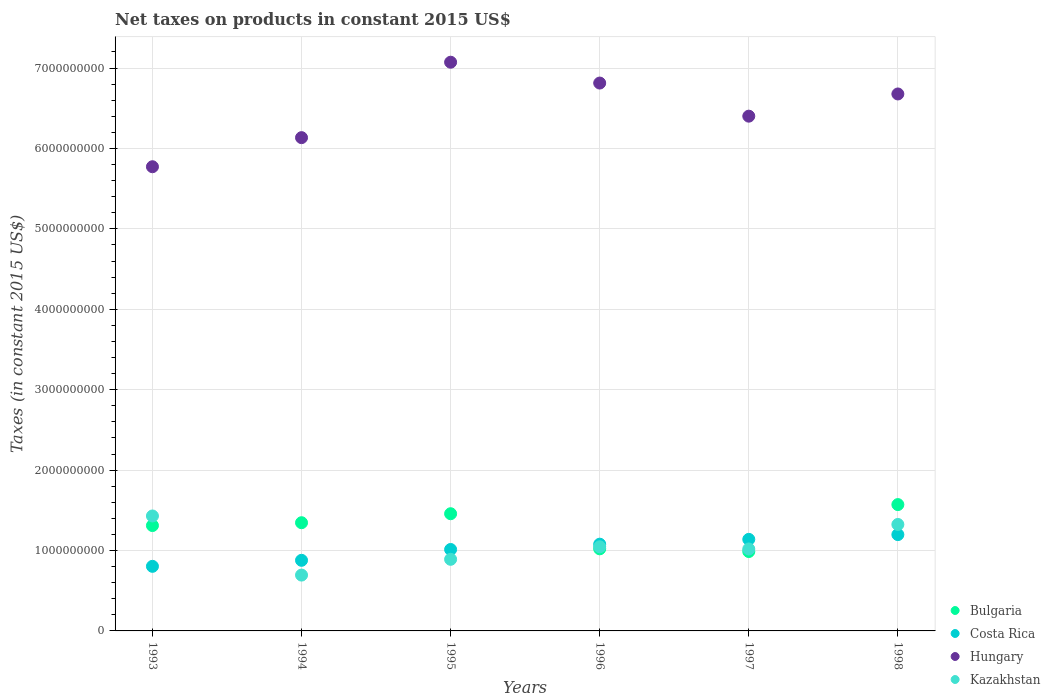How many different coloured dotlines are there?
Keep it short and to the point. 4. What is the net taxes on products in Bulgaria in 1998?
Your answer should be very brief. 1.57e+09. Across all years, what is the maximum net taxes on products in Bulgaria?
Offer a very short reply. 1.57e+09. Across all years, what is the minimum net taxes on products in Kazakhstan?
Your answer should be compact. 6.94e+08. In which year was the net taxes on products in Bulgaria minimum?
Your response must be concise. 1997. What is the total net taxes on products in Kazakhstan in the graph?
Ensure brevity in your answer.  6.40e+09. What is the difference between the net taxes on products in Bulgaria in 1993 and that in 1994?
Give a very brief answer. -3.53e+07. What is the difference between the net taxes on products in Hungary in 1993 and the net taxes on products in Costa Rica in 1996?
Provide a succinct answer. 4.69e+09. What is the average net taxes on products in Costa Rica per year?
Offer a terse response. 1.02e+09. In the year 1993, what is the difference between the net taxes on products in Bulgaria and net taxes on products in Costa Rica?
Offer a very short reply. 5.07e+08. In how many years, is the net taxes on products in Bulgaria greater than 6400000000 US$?
Provide a succinct answer. 0. What is the ratio of the net taxes on products in Kazakhstan in 1994 to that in 1997?
Provide a succinct answer. 0.68. Is the net taxes on products in Hungary in 1993 less than that in 1995?
Make the answer very short. Yes. Is the difference between the net taxes on products in Bulgaria in 1995 and 1998 greater than the difference between the net taxes on products in Costa Rica in 1995 and 1998?
Offer a very short reply. Yes. What is the difference between the highest and the second highest net taxes on products in Bulgaria?
Give a very brief answer. 1.14e+08. What is the difference between the highest and the lowest net taxes on products in Bulgaria?
Your answer should be very brief. 5.84e+08. In how many years, is the net taxes on products in Bulgaria greater than the average net taxes on products in Bulgaria taken over all years?
Provide a succinct answer. 4. Is it the case that in every year, the sum of the net taxes on products in Hungary and net taxes on products in Costa Rica  is greater than the net taxes on products in Bulgaria?
Provide a succinct answer. Yes. Does the net taxes on products in Costa Rica monotonically increase over the years?
Keep it short and to the point. Yes. Is the net taxes on products in Hungary strictly greater than the net taxes on products in Costa Rica over the years?
Your answer should be compact. Yes. How many dotlines are there?
Offer a very short reply. 4. Are the values on the major ticks of Y-axis written in scientific E-notation?
Your response must be concise. No. Does the graph contain any zero values?
Offer a very short reply. No. Does the graph contain grids?
Offer a very short reply. Yes. Where does the legend appear in the graph?
Give a very brief answer. Bottom right. How are the legend labels stacked?
Ensure brevity in your answer.  Vertical. What is the title of the graph?
Make the answer very short. Net taxes on products in constant 2015 US$. Does "Liechtenstein" appear as one of the legend labels in the graph?
Offer a terse response. No. What is the label or title of the Y-axis?
Make the answer very short. Taxes (in constant 2015 US$). What is the Taxes (in constant 2015 US$) in Bulgaria in 1993?
Give a very brief answer. 1.31e+09. What is the Taxes (in constant 2015 US$) in Costa Rica in 1993?
Provide a short and direct response. 8.03e+08. What is the Taxes (in constant 2015 US$) of Hungary in 1993?
Offer a terse response. 5.77e+09. What is the Taxes (in constant 2015 US$) of Kazakhstan in 1993?
Ensure brevity in your answer.  1.43e+09. What is the Taxes (in constant 2015 US$) in Bulgaria in 1994?
Keep it short and to the point. 1.35e+09. What is the Taxes (in constant 2015 US$) of Costa Rica in 1994?
Offer a terse response. 8.78e+08. What is the Taxes (in constant 2015 US$) of Hungary in 1994?
Provide a succinct answer. 6.13e+09. What is the Taxes (in constant 2015 US$) in Kazakhstan in 1994?
Your answer should be compact. 6.94e+08. What is the Taxes (in constant 2015 US$) of Bulgaria in 1995?
Provide a short and direct response. 1.46e+09. What is the Taxes (in constant 2015 US$) of Costa Rica in 1995?
Offer a terse response. 1.01e+09. What is the Taxes (in constant 2015 US$) in Hungary in 1995?
Make the answer very short. 7.07e+09. What is the Taxes (in constant 2015 US$) in Kazakhstan in 1995?
Provide a short and direct response. 8.91e+08. What is the Taxes (in constant 2015 US$) of Bulgaria in 1996?
Your answer should be compact. 1.02e+09. What is the Taxes (in constant 2015 US$) of Costa Rica in 1996?
Give a very brief answer. 1.08e+09. What is the Taxes (in constant 2015 US$) in Hungary in 1996?
Your answer should be very brief. 6.81e+09. What is the Taxes (in constant 2015 US$) in Kazakhstan in 1996?
Your response must be concise. 1.05e+09. What is the Taxes (in constant 2015 US$) of Bulgaria in 1997?
Give a very brief answer. 9.87e+08. What is the Taxes (in constant 2015 US$) in Costa Rica in 1997?
Your answer should be very brief. 1.14e+09. What is the Taxes (in constant 2015 US$) in Hungary in 1997?
Your answer should be very brief. 6.40e+09. What is the Taxes (in constant 2015 US$) in Kazakhstan in 1997?
Make the answer very short. 1.02e+09. What is the Taxes (in constant 2015 US$) of Bulgaria in 1998?
Offer a very short reply. 1.57e+09. What is the Taxes (in constant 2015 US$) of Costa Rica in 1998?
Your response must be concise. 1.20e+09. What is the Taxes (in constant 2015 US$) of Hungary in 1998?
Make the answer very short. 6.68e+09. What is the Taxes (in constant 2015 US$) of Kazakhstan in 1998?
Ensure brevity in your answer.  1.32e+09. Across all years, what is the maximum Taxes (in constant 2015 US$) of Bulgaria?
Ensure brevity in your answer.  1.57e+09. Across all years, what is the maximum Taxes (in constant 2015 US$) of Costa Rica?
Give a very brief answer. 1.20e+09. Across all years, what is the maximum Taxes (in constant 2015 US$) of Hungary?
Provide a succinct answer. 7.07e+09. Across all years, what is the maximum Taxes (in constant 2015 US$) in Kazakhstan?
Your response must be concise. 1.43e+09. Across all years, what is the minimum Taxes (in constant 2015 US$) in Bulgaria?
Your response must be concise. 9.87e+08. Across all years, what is the minimum Taxes (in constant 2015 US$) in Costa Rica?
Provide a short and direct response. 8.03e+08. Across all years, what is the minimum Taxes (in constant 2015 US$) in Hungary?
Offer a terse response. 5.77e+09. Across all years, what is the minimum Taxes (in constant 2015 US$) in Kazakhstan?
Provide a short and direct response. 6.94e+08. What is the total Taxes (in constant 2015 US$) of Bulgaria in the graph?
Ensure brevity in your answer.  7.69e+09. What is the total Taxes (in constant 2015 US$) in Costa Rica in the graph?
Provide a short and direct response. 6.11e+09. What is the total Taxes (in constant 2015 US$) of Hungary in the graph?
Give a very brief answer. 3.89e+1. What is the total Taxes (in constant 2015 US$) of Kazakhstan in the graph?
Provide a succinct answer. 6.40e+09. What is the difference between the Taxes (in constant 2015 US$) of Bulgaria in 1993 and that in 1994?
Your response must be concise. -3.53e+07. What is the difference between the Taxes (in constant 2015 US$) in Costa Rica in 1993 and that in 1994?
Offer a very short reply. -7.48e+07. What is the difference between the Taxes (in constant 2015 US$) of Hungary in 1993 and that in 1994?
Keep it short and to the point. -3.62e+08. What is the difference between the Taxes (in constant 2015 US$) of Kazakhstan in 1993 and that in 1994?
Provide a short and direct response. 7.35e+08. What is the difference between the Taxes (in constant 2015 US$) of Bulgaria in 1993 and that in 1995?
Provide a succinct answer. -1.47e+08. What is the difference between the Taxes (in constant 2015 US$) in Costa Rica in 1993 and that in 1995?
Provide a short and direct response. -2.10e+08. What is the difference between the Taxes (in constant 2015 US$) of Hungary in 1993 and that in 1995?
Your response must be concise. -1.30e+09. What is the difference between the Taxes (in constant 2015 US$) of Kazakhstan in 1993 and that in 1995?
Ensure brevity in your answer.  5.39e+08. What is the difference between the Taxes (in constant 2015 US$) of Bulgaria in 1993 and that in 1996?
Your response must be concise. 2.89e+08. What is the difference between the Taxes (in constant 2015 US$) in Costa Rica in 1993 and that in 1996?
Make the answer very short. -2.75e+08. What is the difference between the Taxes (in constant 2015 US$) of Hungary in 1993 and that in 1996?
Offer a terse response. -1.04e+09. What is the difference between the Taxes (in constant 2015 US$) of Kazakhstan in 1993 and that in 1996?
Ensure brevity in your answer.  3.83e+08. What is the difference between the Taxes (in constant 2015 US$) in Bulgaria in 1993 and that in 1997?
Keep it short and to the point. 3.23e+08. What is the difference between the Taxes (in constant 2015 US$) in Costa Rica in 1993 and that in 1997?
Offer a very short reply. -3.35e+08. What is the difference between the Taxes (in constant 2015 US$) in Hungary in 1993 and that in 1997?
Provide a short and direct response. -6.29e+08. What is the difference between the Taxes (in constant 2015 US$) of Kazakhstan in 1993 and that in 1997?
Provide a succinct answer. 4.10e+08. What is the difference between the Taxes (in constant 2015 US$) of Bulgaria in 1993 and that in 1998?
Give a very brief answer. -2.61e+08. What is the difference between the Taxes (in constant 2015 US$) of Costa Rica in 1993 and that in 1998?
Your response must be concise. -3.95e+08. What is the difference between the Taxes (in constant 2015 US$) of Hungary in 1993 and that in 1998?
Provide a succinct answer. -9.05e+08. What is the difference between the Taxes (in constant 2015 US$) in Kazakhstan in 1993 and that in 1998?
Provide a succinct answer. 1.06e+08. What is the difference between the Taxes (in constant 2015 US$) in Bulgaria in 1994 and that in 1995?
Give a very brief answer. -1.12e+08. What is the difference between the Taxes (in constant 2015 US$) in Costa Rica in 1994 and that in 1995?
Your answer should be compact. -1.35e+08. What is the difference between the Taxes (in constant 2015 US$) of Hungary in 1994 and that in 1995?
Offer a very short reply. -9.38e+08. What is the difference between the Taxes (in constant 2015 US$) of Kazakhstan in 1994 and that in 1995?
Your response must be concise. -1.96e+08. What is the difference between the Taxes (in constant 2015 US$) in Bulgaria in 1994 and that in 1996?
Ensure brevity in your answer.  3.25e+08. What is the difference between the Taxes (in constant 2015 US$) in Costa Rica in 1994 and that in 1996?
Your answer should be compact. -2.01e+08. What is the difference between the Taxes (in constant 2015 US$) in Hungary in 1994 and that in 1996?
Keep it short and to the point. -6.79e+08. What is the difference between the Taxes (in constant 2015 US$) in Kazakhstan in 1994 and that in 1996?
Offer a very short reply. -3.52e+08. What is the difference between the Taxes (in constant 2015 US$) in Bulgaria in 1994 and that in 1997?
Provide a succinct answer. 3.59e+08. What is the difference between the Taxes (in constant 2015 US$) of Costa Rica in 1994 and that in 1997?
Give a very brief answer. -2.61e+08. What is the difference between the Taxes (in constant 2015 US$) of Hungary in 1994 and that in 1997?
Provide a succinct answer. -2.67e+08. What is the difference between the Taxes (in constant 2015 US$) of Kazakhstan in 1994 and that in 1997?
Your answer should be very brief. -3.25e+08. What is the difference between the Taxes (in constant 2015 US$) of Bulgaria in 1994 and that in 1998?
Offer a terse response. -2.25e+08. What is the difference between the Taxes (in constant 2015 US$) in Costa Rica in 1994 and that in 1998?
Your answer should be very brief. -3.20e+08. What is the difference between the Taxes (in constant 2015 US$) of Hungary in 1994 and that in 1998?
Your answer should be compact. -5.43e+08. What is the difference between the Taxes (in constant 2015 US$) of Kazakhstan in 1994 and that in 1998?
Provide a short and direct response. -6.30e+08. What is the difference between the Taxes (in constant 2015 US$) of Bulgaria in 1995 and that in 1996?
Give a very brief answer. 4.36e+08. What is the difference between the Taxes (in constant 2015 US$) of Costa Rica in 1995 and that in 1996?
Keep it short and to the point. -6.58e+07. What is the difference between the Taxes (in constant 2015 US$) in Hungary in 1995 and that in 1996?
Your response must be concise. 2.59e+08. What is the difference between the Taxes (in constant 2015 US$) of Kazakhstan in 1995 and that in 1996?
Your response must be concise. -1.56e+08. What is the difference between the Taxes (in constant 2015 US$) in Bulgaria in 1995 and that in 1997?
Give a very brief answer. 4.70e+08. What is the difference between the Taxes (in constant 2015 US$) in Costa Rica in 1995 and that in 1997?
Keep it short and to the point. -1.26e+08. What is the difference between the Taxes (in constant 2015 US$) in Hungary in 1995 and that in 1997?
Offer a terse response. 6.71e+08. What is the difference between the Taxes (in constant 2015 US$) in Kazakhstan in 1995 and that in 1997?
Offer a very short reply. -1.29e+08. What is the difference between the Taxes (in constant 2015 US$) of Bulgaria in 1995 and that in 1998?
Your answer should be very brief. -1.14e+08. What is the difference between the Taxes (in constant 2015 US$) of Costa Rica in 1995 and that in 1998?
Keep it short and to the point. -1.85e+08. What is the difference between the Taxes (in constant 2015 US$) in Hungary in 1995 and that in 1998?
Offer a terse response. 3.95e+08. What is the difference between the Taxes (in constant 2015 US$) of Kazakhstan in 1995 and that in 1998?
Your answer should be very brief. -4.33e+08. What is the difference between the Taxes (in constant 2015 US$) in Bulgaria in 1996 and that in 1997?
Make the answer very short. 3.38e+07. What is the difference between the Taxes (in constant 2015 US$) of Costa Rica in 1996 and that in 1997?
Make the answer very short. -6.00e+07. What is the difference between the Taxes (in constant 2015 US$) in Hungary in 1996 and that in 1997?
Offer a terse response. 4.12e+08. What is the difference between the Taxes (in constant 2015 US$) of Kazakhstan in 1996 and that in 1997?
Give a very brief answer. 2.69e+07. What is the difference between the Taxes (in constant 2015 US$) of Bulgaria in 1996 and that in 1998?
Provide a succinct answer. -5.50e+08. What is the difference between the Taxes (in constant 2015 US$) in Costa Rica in 1996 and that in 1998?
Offer a terse response. -1.19e+08. What is the difference between the Taxes (in constant 2015 US$) of Hungary in 1996 and that in 1998?
Make the answer very short. 1.36e+08. What is the difference between the Taxes (in constant 2015 US$) of Kazakhstan in 1996 and that in 1998?
Offer a terse response. -2.78e+08. What is the difference between the Taxes (in constant 2015 US$) of Bulgaria in 1997 and that in 1998?
Your response must be concise. -5.84e+08. What is the difference between the Taxes (in constant 2015 US$) of Costa Rica in 1997 and that in 1998?
Offer a terse response. -5.92e+07. What is the difference between the Taxes (in constant 2015 US$) of Hungary in 1997 and that in 1998?
Offer a terse response. -2.76e+08. What is the difference between the Taxes (in constant 2015 US$) in Kazakhstan in 1997 and that in 1998?
Your answer should be very brief. -3.05e+08. What is the difference between the Taxes (in constant 2015 US$) in Bulgaria in 1993 and the Taxes (in constant 2015 US$) in Costa Rica in 1994?
Give a very brief answer. 4.32e+08. What is the difference between the Taxes (in constant 2015 US$) in Bulgaria in 1993 and the Taxes (in constant 2015 US$) in Hungary in 1994?
Offer a terse response. -4.82e+09. What is the difference between the Taxes (in constant 2015 US$) in Bulgaria in 1993 and the Taxes (in constant 2015 US$) in Kazakhstan in 1994?
Your answer should be very brief. 6.16e+08. What is the difference between the Taxes (in constant 2015 US$) in Costa Rica in 1993 and the Taxes (in constant 2015 US$) in Hungary in 1994?
Give a very brief answer. -5.33e+09. What is the difference between the Taxes (in constant 2015 US$) in Costa Rica in 1993 and the Taxes (in constant 2015 US$) in Kazakhstan in 1994?
Give a very brief answer. 1.09e+08. What is the difference between the Taxes (in constant 2015 US$) of Hungary in 1993 and the Taxes (in constant 2015 US$) of Kazakhstan in 1994?
Offer a very short reply. 5.08e+09. What is the difference between the Taxes (in constant 2015 US$) in Bulgaria in 1993 and the Taxes (in constant 2015 US$) in Costa Rica in 1995?
Your response must be concise. 2.98e+08. What is the difference between the Taxes (in constant 2015 US$) in Bulgaria in 1993 and the Taxes (in constant 2015 US$) in Hungary in 1995?
Offer a terse response. -5.76e+09. What is the difference between the Taxes (in constant 2015 US$) of Bulgaria in 1993 and the Taxes (in constant 2015 US$) of Kazakhstan in 1995?
Make the answer very short. 4.20e+08. What is the difference between the Taxes (in constant 2015 US$) of Costa Rica in 1993 and the Taxes (in constant 2015 US$) of Hungary in 1995?
Your answer should be very brief. -6.27e+09. What is the difference between the Taxes (in constant 2015 US$) of Costa Rica in 1993 and the Taxes (in constant 2015 US$) of Kazakhstan in 1995?
Offer a very short reply. -8.73e+07. What is the difference between the Taxes (in constant 2015 US$) in Hungary in 1993 and the Taxes (in constant 2015 US$) in Kazakhstan in 1995?
Provide a short and direct response. 4.88e+09. What is the difference between the Taxes (in constant 2015 US$) in Bulgaria in 1993 and the Taxes (in constant 2015 US$) in Costa Rica in 1996?
Provide a short and direct response. 2.32e+08. What is the difference between the Taxes (in constant 2015 US$) in Bulgaria in 1993 and the Taxes (in constant 2015 US$) in Hungary in 1996?
Offer a terse response. -5.50e+09. What is the difference between the Taxes (in constant 2015 US$) in Bulgaria in 1993 and the Taxes (in constant 2015 US$) in Kazakhstan in 1996?
Provide a short and direct response. 2.64e+08. What is the difference between the Taxes (in constant 2015 US$) in Costa Rica in 1993 and the Taxes (in constant 2015 US$) in Hungary in 1996?
Provide a succinct answer. -6.01e+09. What is the difference between the Taxes (in constant 2015 US$) of Costa Rica in 1993 and the Taxes (in constant 2015 US$) of Kazakhstan in 1996?
Offer a terse response. -2.43e+08. What is the difference between the Taxes (in constant 2015 US$) in Hungary in 1993 and the Taxes (in constant 2015 US$) in Kazakhstan in 1996?
Your answer should be compact. 4.73e+09. What is the difference between the Taxes (in constant 2015 US$) of Bulgaria in 1993 and the Taxes (in constant 2015 US$) of Costa Rica in 1997?
Provide a succinct answer. 1.72e+08. What is the difference between the Taxes (in constant 2015 US$) of Bulgaria in 1993 and the Taxes (in constant 2015 US$) of Hungary in 1997?
Provide a succinct answer. -5.09e+09. What is the difference between the Taxes (in constant 2015 US$) in Bulgaria in 1993 and the Taxes (in constant 2015 US$) in Kazakhstan in 1997?
Your response must be concise. 2.91e+08. What is the difference between the Taxes (in constant 2015 US$) of Costa Rica in 1993 and the Taxes (in constant 2015 US$) of Hungary in 1997?
Provide a succinct answer. -5.60e+09. What is the difference between the Taxes (in constant 2015 US$) in Costa Rica in 1993 and the Taxes (in constant 2015 US$) in Kazakhstan in 1997?
Keep it short and to the point. -2.16e+08. What is the difference between the Taxes (in constant 2015 US$) of Hungary in 1993 and the Taxes (in constant 2015 US$) of Kazakhstan in 1997?
Ensure brevity in your answer.  4.75e+09. What is the difference between the Taxes (in constant 2015 US$) in Bulgaria in 1993 and the Taxes (in constant 2015 US$) in Costa Rica in 1998?
Your answer should be compact. 1.13e+08. What is the difference between the Taxes (in constant 2015 US$) in Bulgaria in 1993 and the Taxes (in constant 2015 US$) in Hungary in 1998?
Ensure brevity in your answer.  -5.37e+09. What is the difference between the Taxes (in constant 2015 US$) in Bulgaria in 1993 and the Taxes (in constant 2015 US$) in Kazakhstan in 1998?
Keep it short and to the point. -1.35e+07. What is the difference between the Taxes (in constant 2015 US$) of Costa Rica in 1993 and the Taxes (in constant 2015 US$) of Hungary in 1998?
Your answer should be compact. -5.87e+09. What is the difference between the Taxes (in constant 2015 US$) in Costa Rica in 1993 and the Taxes (in constant 2015 US$) in Kazakhstan in 1998?
Ensure brevity in your answer.  -5.21e+08. What is the difference between the Taxes (in constant 2015 US$) of Hungary in 1993 and the Taxes (in constant 2015 US$) of Kazakhstan in 1998?
Your response must be concise. 4.45e+09. What is the difference between the Taxes (in constant 2015 US$) in Bulgaria in 1994 and the Taxes (in constant 2015 US$) in Costa Rica in 1995?
Provide a succinct answer. 3.33e+08. What is the difference between the Taxes (in constant 2015 US$) of Bulgaria in 1994 and the Taxes (in constant 2015 US$) of Hungary in 1995?
Give a very brief answer. -5.73e+09. What is the difference between the Taxes (in constant 2015 US$) of Bulgaria in 1994 and the Taxes (in constant 2015 US$) of Kazakhstan in 1995?
Give a very brief answer. 4.55e+08. What is the difference between the Taxes (in constant 2015 US$) of Costa Rica in 1994 and the Taxes (in constant 2015 US$) of Hungary in 1995?
Provide a short and direct response. -6.19e+09. What is the difference between the Taxes (in constant 2015 US$) of Costa Rica in 1994 and the Taxes (in constant 2015 US$) of Kazakhstan in 1995?
Keep it short and to the point. -1.25e+07. What is the difference between the Taxes (in constant 2015 US$) of Hungary in 1994 and the Taxes (in constant 2015 US$) of Kazakhstan in 1995?
Your answer should be very brief. 5.24e+09. What is the difference between the Taxes (in constant 2015 US$) in Bulgaria in 1994 and the Taxes (in constant 2015 US$) in Costa Rica in 1996?
Give a very brief answer. 2.67e+08. What is the difference between the Taxes (in constant 2015 US$) of Bulgaria in 1994 and the Taxes (in constant 2015 US$) of Hungary in 1996?
Make the answer very short. -5.47e+09. What is the difference between the Taxes (in constant 2015 US$) of Bulgaria in 1994 and the Taxes (in constant 2015 US$) of Kazakhstan in 1996?
Make the answer very short. 3.00e+08. What is the difference between the Taxes (in constant 2015 US$) of Costa Rica in 1994 and the Taxes (in constant 2015 US$) of Hungary in 1996?
Offer a terse response. -5.94e+09. What is the difference between the Taxes (in constant 2015 US$) in Costa Rica in 1994 and the Taxes (in constant 2015 US$) in Kazakhstan in 1996?
Your answer should be very brief. -1.68e+08. What is the difference between the Taxes (in constant 2015 US$) in Hungary in 1994 and the Taxes (in constant 2015 US$) in Kazakhstan in 1996?
Your response must be concise. 5.09e+09. What is the difference between the Taxes (in constant 2015 US$) of Bulgaria in 1994 and the Taxes (in constant 2015 US$) of Costa Rica in 1997?
Your answer should be very brief. 2.07e+08. What is the difference between the Taxes (in constant 2015 US$) in Bulgaria in 1994 and the Taxes (in constant 2015 US$) in Hungary in 1997?
Ensure brevity in your answer.  -5.06e+09. What is the difference between the Taxes (in constant 2015 US$) in Bulgaria in 1994 and the Taxes (in constant 2015 US$) in Kazakhstan in 1997?
Provide a succinct answer. 3.27e+08. What is the difference between the Taxes (in constant 2015 US$) in Costa Rica in 1994 and the Taxes (in constant 2015 US$) in Hungary in 1997?
Keep it short and to the point. -5.52e+09. What is the difference between the Taxes (in constant 2015 US$) of Costa Rica in 1994 and the Taxes (in constant 2015 US$) of Kazakhstan in 1997?
Your answer should be compact. -1.41e+08. What is the difference between the Taxes (in constant 2015 US$) in Hungary in 1994 and the Taxes (in constant 2015 US$) in Kazakhstan in 1997?
Your answer should be very brief. 5.12e+09. What is the difference between the Taxes (in constant 2015 US$) in Bulgaria in 1994 and the Taxes (in constant 2015 US$) in Costa Rica in 1998?
Ensure brevity in your answer.  1.48e+08. What is the difference between the Taxes (in constant 2015 US$) of Bulgaria in 1994 and the Taxes (in constant 2015 US$) of Hungary in 1998?
Make the answer very short. -5.33e+09. What is the difference between the Taxes (in constant 2015 US$) in Bulgaria in 1994 and the Taxes (in constant 2015 US$) in Kazakhstan in 1998?
Keep it short and to the point. 2.17e+07. What is the difference between the Taxes (in constant 2015 US$) in Costa Rica in 1994 and the Taxes (in constant 2015 US$) in Hungary in 1998?
Your answer should be compact. -5.80e+09. What is the difference between the Taxes (in constant 2015 US$) in Costa Rica in 1994 and the Taxes (in constant 2015 US$) in Kazakhstan in 1998?
Offer a very short reply. -4.46e+08. What is the difference between the Taxes (in constant 2015 US$) of Hungary in 1994 and the Taxes (in constant 2015 US$) of Kazakhstan in 1998?
Your answer should be compact. 4.81e+09. What is the difference between the Taxes (in constant 2015 US$) in Bulgaria in 1995 and the Taxes (in constant 2015 US$) in Costa Rica in 1996?
Keep it short and to the point. 3.79e+08. What is the difference between the Taxes (in constant 2015 US$) in Bulgaria in 1995 and the Taxes (in constant 2015 US$) in Hungary in 1996?
Provide a succinct answer. -5.36e+09. What is the difference between the Taxes (in constant 2015 US$) in Bulgaria in 1995 and the Taxes (in constant 2015 US$) in Kazakhstan in 1996?
Offer a very short reply. 4.11e+08. What is the difference between the Taxes (in constant 2015 US$) in Costa Rica in 1995 and the Taxes (in constant 2015 US$) in Hungary in 1996?
Provide a succinct answer. -5.80e+09. What is the difference between the Taxes (in constant 2015 US$) in Costa Rica in 1995 and the Taxes (in constant 2015 US$) in Kazakhstan in 1996?
Offer a terse response. -3.33e+07. What is the difference between the Taxes (in constant 2015 US$) in Hungary in 1995 and the Taxes (in constant 2015 US$) in Kazakhstan in 1996?
Give a very brief answer. 6.03e+09. What is the difference between the Taxes (in constant 2015 US$) of Bulgaria in 1995 and the Taxes (in constant 2015 US$) of Costa Rica in 1997?
Make the answer very short. 3.19e+08. What is the difference between the Taxes (in constant 2015 US$) of Bulgaria in 1995 and the Taxes (in constant 2015 US$) of Hungary in 1997?
Offer a terse response. -4.94e+09. What is the difference between the Taxes (in constant 2015 US$) of Bulgaria in 1995 and the Taxes (in constant 2015 US$) of Kazakhstan in 1997?
Your response must be concise. 4.38e+08. What is the difference between the Taxes (in constant 2015 US$) in Costa Rica in 1995 and the Taxes (in constant 2015 US$) in Hungary in 1997?
Make the answer very short. -5.39e+09. What is the difference between the Taxes (in constant 2015 US$) of Costa Rica in 1995 and the Taxes (in constant 2015 US$) of Kazakhstan in 1997?
Give a very brief answer. -6.32e+06. What is the difference between the Taxes (in constant 2015 US$) of Hungary in 1995 and the Taxes (in constant 2015 US$) of Kazakhstan in 1997?
Make the answer very short. 6.05e+09. What is the difference between the Taxes (in constant 2015 US$) in Bulgaria in 1995 and the Taxes (in constant 2015 US$) in Costa Rica in 1998?
Provide a succinct answer. 2.60e+08. What is the difference between the Taxes (in constant 2015 US$) of Bulgaria in 1995 and the Taxes (in constant 2015 US$) of Hungary in 1998?
Provide a succinct answer. -5.22e+09. What is the difference between the Taxes (in constant 2015 US$) of Bulgaria in 1995 and the Taxes (in constant 2015 US$) of Kazakhstan in 1998?
Offer a terse response. 1.34e+08. What is the difference between the Taxes (in constant 2015 US$) of Costa Rica in 1995 and the Taxes (in constant 2015 US$) of Hungary in 1998?
Keep it short and to the point. -5.67e+09. What is the difference between the Taxes (in constant 2015 US$) of Costa Rica in 1995 and the Taxes (in constant 2015 US$) of Kazakhstan in 1998?
Give a very brief answer. -3.11e+08. What is the difference between the Taxes (in constant 2015 US$) of Hungary in 1995 and the Taxes (in constant 2015 US$) of Kazakhstan in 1998?
Your response must be concise. 5.75e+09. What is the difference between the Taxes (in constant 2015 US$) in Bulgaria in 1996 and the Taxes (in constant 2015 US$) in Costa Rica in 1997?
Offer a very short reply. -1.18e+08. What is the difference between the Taxes (in constant 2015 US$) in Bulgaria in 1996 and the Taxes (in constant 2015 US$) in Hungary in 1997?
Your response must be concise. -5.38e+09. What is the difference between the Taxes (in constant 2015 US$) in Bulgaria in 1996 and the Taxes (in constant 2015 US$) in Kazakhstan in 1997?
Make the answer very short. 1.86e+06. What is the difference between the Taxes (in constant 2015 US$) in Costa Rica in 1996 and the Taxes (in constant 2015 US$) in Hungary in 1997?
Your response must be concise. -5.32e+09. What is the difference between the Taxes (in constant 2015 US$) in Costa Rica in 1996 and the Taxes (in constant 2015 US$) in Kazakhstan in 1997?
Ensure brevity in your answer.  5.95e+07. What is the difference between the Taxes (in constant 2015 US$) in Hungary in 1996 and the Taxes (in constant 2015 US$) in Kazakhstan in 1997?
Offer a terse response. 5.79e+09. What is the difference between the Taxes (in constant 2015 US$) in Bulgaria in 1996 and the Taxes (in constant 2015 US$) in Costa Rica in 1998?
Your answer should be very brief. -1.77e+08. What is the difference between the Taxes (in constant 2015 US$) in Bulgaria in 1996 and the Taxes (in constant 2015 US$) in Hungary in 1998?
Provide a short and direct response. -5.66e+09. What is the difference between the Taxes (in constant 2015 US$) in Bulgaria in 1996 and the Taxes (in constant 2015 US$) in Kazakhstan in 1998?
Ensure brevity in your answer.  -3.03e+08. What is the difference between the Taxes (in constant 2015 US$) of Costa Rica in 1996 and the Taxes (in constant 2015 US$) of Hungary in 1998?
Ensure brevity in your answer.  -5.60e+09. What is the difference between the Taxes (in constant 2015 US$) in Costa Rica in 1996 and the Taxes (in constant 2015 US$) in Kazakhstan in 1998?
Make the answer very short. -2.45e+08. What is the difference between the Taxes (in constant 2015 US$) in Hungary in 1996 and the Taxes (in constant 2015 US$) in Kazakhstan in 1998?
Keep it short and to the point. 5.49e+09. What is the difference between the Taxes (in constant 2015 US$) in Bulgaria in 1997 and the Taxes (in constant 2015 US$) in Costa Rica in 1998?
Ensure brevity in your answer.  -2.11e+08. What is the difference between the Taxes (in constant 2015 US$) of Bulgaria in 1997 and the Taxes (in constant 2015 US$) of Hungary in 1998?
Ensure brevity in your answer.  -5.69e+09. What is the difference between the Taxes (in constant 2015 US$) in Bulgaria in 1997 and the Taxes (in constant 2015 US$) in Kazakhstan in 1998?
Give a very brief answer. -3.37e+08. What is the difference between the Taxes (in constant 2015 US$) of Costa Rica in 1997 and the Taxes (in constant 2015 US$) of Hungary in 1998?
Make the answer very short. -5.54e+09. What is the difference between the Taxes (in constant 2015 US$) of Costa Rica in 1997 and the Taxes (in constant 2015 US$) of Kazakhstan in 1998?
Offer a terse response. -1.85e+08. What is the difference between the Taxes (in constant 2015 US$) of Hungary in 1997 and the Taxes (in constant 2015 US$) of Kazakhstan in 1998?
Ensure brevity in your answer.  5.08e+09. What is the average Taxes (in constant 2015 US$) of Bulgaria per year?
Provide a short and direct response. 1.28e+09. What is the average Taxes (in constant 2015 US$) in Costa Rica per year?
Make the answer very short. 1.02e+09. What is the average Taxes (in constant 2015 US$) of Hungary per year?
Give a very brief answer. 6.48e+09. What is the average Taxes (in constant 2015 US$) in Kazakhstan per year?
Your response must be concise. 1.07e+09. In the year 1993, what is the difference between the Taxes (in constant 2015 US$) of Bulgaria and Taxes (in constant 2015 US$) of Costa Rica?
Your response must be concise. 5.07e+08. In the year 1993, what is the difference between the Taxes (in constant 2015 US$) in Bulgaria and Taxes (in constant 2015 US$) in Hungary?
Give a very brief answer. -4.46e+09. In the year 1993, what is the difference between the Taxes (in constant 2015 US$) of Bulgaria and Taxes (in constant 2015 US$) of Kazakhstan?
Ensure brevity in your answer.  -1.19e+08. In the year 1993, what is the difference between the Taxes (in constant 2015 US$) in Costa Rica and Taxes (in constant 2015 US$) in Hungary?
Make the answer very short. -4.97e+09. In the year 1993, what is the difference between the Taxes (in constant 2015 US$) in Costa Rica and Taxes (in constant 2015 US$) in Kazakhstan?
Give a very brief answer. -6.26e+08. In the year 1993, what is the difference between the Taxes (in constant 2015 US$) of Hungary and Taxes (in constant 2015 US$) of Kazakhstan?
Your answer should be very brief. 4.34e+09. In the year 1994, what is the difference between the Taxes (in constant 2015 US$) of Bulgaria and Taxes (in constant 2015 US$) of Costa Rica?
Keep it short and to the point. 4.68e+08. In the year 1994, what is the difference between the Taxes (in constant 2015 US$) in Bulgaria and Taxes (in constant 2015 US$) in Hungary?
Keep it short and to the point. -4.79e+09. In the year 1994, what is the difference between the Taxes (in constant 2015 US$) of Bulgaria and Taxes (in constant 2015 US$) of Kazakhstan?
Give a very brief answer. 6.51e+08. In the year 1994, what is the difference between the Taxes (in constant 2015 US$) in Costa Rica and Taxes (in constant 2015 US$) in Hungary?
Provide a short and direct response. -5.26e+09. In the year 1994, what is the difference between the Taxes (in constant 2015 US$) of Costa Rica and Taxes (in constant 2015 US$) of Kazakhstan?
Ensure brevity in your answer.  1.84e+08. In the year 1994, what is the difference between the Taxes (in constant 2015 US$) of Hungary and Taxes (in constant 2015 US$) of Kazakhstan?
Make the answer very short. 5.44e+09. In the year 1995, what is the difference between the Taxes (in constant 2015 US$) of Bulgaria and Taxes (in constant 2015 US$) of Costa Rica?
Make the answer very short. 4.45e+08. In the year 1995, what is the difference between the Taxes (in constant 2015 US$) of Bulgaria and Taxes (in constant 2015 US$) of Hungary?
Your answer should be compact. -5.62e+09. In the year 1995, what is the difference between the Taxes (in constant 2015 US$) of Bulgaria and Taxes (in constant 2015 US$) of Kazakhstan?
Keep it short and to the point. 5.67e+08. In the year 1995, what is the difference between the Taxes (in constant 2015 US$) in Costa Rica and Taxes (in constant 2015 US$) in Hungary?
Offer a terse response. -6.06e+09. In the year 1995, what is the difference between the Taxes (in constant 2015 US$) of Costa Rica and Taxes (in constant 2015 US$) of Kazakhstan?
Your response must be concise. 1.22e+08. In the year 1995, what is the difference between the Taxes (in constant 2015 US$) in Hungary and Taxes (in constant 2015 US$) in Kazakhstan?
Offer a terse response. 6.18e+09. In the year 1996, what is the difference between the Taxes (in constant 2015 US$) in Bulgaria and Taxes (in constant 2015 US$) in Costa Rica?
Your response must be concise. -5.77e+07. In the year 1996, what is the difference between the Taxes (in constant 2015 US$) of Bulgaria and Taxes (in constant 2015 US$) of Hungary?
Your answer should be very brief. -5.79e+09. In the year 1996, what is the difference between the Taxes (in constant 2015 US$) of Bulgaria and Taxes (in constant 2015 US$) of Kazakhstan?
Provide a succinct answer. -2.51e+07. In the year 1996, what is the difference between the Taxes (in constant 2015 US$) of Costa Rica and Taxes (in constant 2015 US$) of Hungary?
Your response must be concise. -5.74e+09. In the year 1996, what is the difference between the Taxes (in constant 2015 US$) in Costa Rica and Taxes (in constant 2015 US$) in Kazakhstan?
Give a very brief answer. 3.26e+07. In the year 1996, what is the difference between the Taxes (in constant 2015 US$) of Hungary and Taxes (in constant 2015 US$) of Kazakhstan?
Ensure brevity in your answer.  5.77e+09. In the year 1997, what is the difference between the Taxes (in constant 2015 US$) of Bulgaria and Taxes (in constant 2015 US$) of Costa Rica?
Your answer should be very brief. -1.52e+08. In the year 1997, what is the difference between the Taxes (in constant 2015 US$) in Bulgaria and Taxes (in constant 2015 US$) in Hungary?
Give a very brief answer. -5.41e+09. In the year 1997, what is the difference between the Taxes (in constant 2015 US$) in Bulgaria and Taxes (in constant 2015 US$) in Kazakhstan?
Offer a very short reply. -3.20e+07. In the year 1997, what is the difference between the Taxes (in constant 2015 US$) in Costa Rica and Taxes (in constant 2015 US$) in Hungary?
Provide a short and direct response. -5.26e+09. In the year 1997, what is the difference between the Taxes (in constant 2015 US$) of Costa Rica and Taxes (in constant 2015 US$) of Kazakhstan?
Make the answer very short. 1.20e+08. In the year 1997, what is the difference between the Taxes (in constant 2015 US$) of Hungary and Taxes (in constant 2015 US$) of Kazakhstan?
Your answer should be compact. 5.38e+09. In the year 1998, what is the difference between the Taxes (in constant 2015 US$) of Bulgaria and Taxes (in constant 2015 US$) of Costa Rica?
Provide a succinct answer. 3.73e+08. In the year 1998, what is the difference between the Taxes (in constant 2015 US$) of Bulgaria and Taxes (in constant 2015 US$) of Hungary?
Your response must be concise. -5.11e+09. In the year 1998, what is the difference between the Taxes (in constant 2015 US$) in Bulgaria and Taxes (in constant 2015 US$) in Kazakhstan?
Provide a short and direct response. 2.47e+08. In the year 1998, what is the difference between the Taxes (in constant 2015 US$) in Costa Rica and Taxes (in constant 2015 US$) in Hungary?
Keep it short and to the point. -5.48e+09. In the year 1998, what is the difference between the Taxes (in constant 2015 US$) of Costa Rica and Taxes (in constant 2015 US$) of Kazakhstan?
Offer a very short reply. -1.26e+08. In the year 1998, what is the difference between the Taxes (in constant 2015 US$) in Hungary and Taxes (in constant 2015 US$) in Kazakhstan?
Keep it short and to the point. 5.35e+09. What is the ratio of the Taxes (in constant 2015 US$) of Bulgaria in 1993 to that in 1994?
Provide a succinct answer. 0.97. What is the ratio of the Taxes (in constant 2015 US$) of Costa Rica in 1993 to that in 1994?
Your response must be concise. 0.91. What is the ratio of the Taxes (in constant 2015 US$) of Hungary in 1993 to that in 1994?
Ensure brevity in your answer.  0.94. What is the ratio of the Taxes (in constant 2015 US$) of Kazakhstan in 1993 to that in 1994?
Your response must be concise. 2.06. What is the ratio of the Taxes (in constant 2015 US$) of Bulgaria in 1993 to that in 1995?
Offer a very short reply. 0.9. What is the ratio of the Taxes (in constant 2015 US$) of Costa Rica in 1993 to that in 1995?
Your response must be concise. 0.79. What is the ratio of the Taxes (in constant 2015 US$) in Hungary in 1993 to that in 1995?
Ensure brevity in your answer.  0.82. What is the ratio of the Taxes (in constant 2015 US$) in Kazakhstan in 1993 to that in 1995?
Make the answer very short. 1.61. What is the ratio of the Taxes (in constant 2015 US$) of Bulgaria in 1993 to that in 1996?
Your response must be concise. 1.28. What is the ratio of the Taxes (in constant 2015 US$) of Costa Rica in 1993 to that in 1996?
Provide a succinct answer. 0.74. What is the ratio of the Taxes (in constant 2015 US$) in Hungary in 1993 to that in 1996?
Your response must be concise. 0.85. What is the ratio of the Taxes (in constant 2015 US$) in Kazakhstan in 1993 to that in 1996?
Provide a succinct answer. 1.37. What is the ratio of the Taxes (in constant 2015 US$) in Bulgaria in 1993 to that in 1997?
Make the answer very short. 1.33. What is the ratio of the Taxes (in constant 2015 US$) of Costa Rica in 1993 to that in 1997?
Your answer should be very brief. 0.71. What is the ratio of the Taxes (in constant 2015 US$) of Hungary in 1993 to that in 1997?
Your answer should be compact. 0.9. What is the ratio of the Taxes (in constant 2015 US$) in Kazakhstan in 1993 to that in 1997?
Make the answer very short. 1.4. What is the ratio of the Taxes (in constant 2015 US$) in Bulgaria in 1993 to that in 1998?
Give a very brief answer. 0.83. What is the ratio of the Taxes (in constant 2015 US$) in Costa Rica in 1993 to that in 1998?
Keep it short and to the point. 0.67. What is the ratio of the Taxes (in constant 2015 US$) of Hungary in 1993 to that in 1998?
Give a very brief answer. 0.86. What is the ratio of the Taxes (in constant 2015 US$) of Kazakhstan in 1993 to that in 1998?
Provide a succinct answer. 1.08. What is the ratio of the Taxes (in constant 2015 US$) in Bulgaria in 1994 to that in 1995?
Ensure brevity in your answer.  0.92. What is the ratio of the Taxes (in constant 2015 US$) in Costa Rica in 1994 to that in 1995?
Make the answer very short. 0.87. What is the ratio of the Taxes (in constant 2015 US$) of Hungary in 1994 to that in 1995?
Provide a short and direct response. 0.87. What is the ratio of the Taxes (in constant 2015 US$) of Kazakhstan in 1994 to that in 1995?
Offer a very short reply. 0.78. What is the ratio of the Taxes (in constant 2015 US$) in Bulgaria in 1994 to that in 1996?
Provide a short and direct response. 1.32. What is the ratio of the Taxes (in constant 2015 US$) of Costa Rica in 1994 to that in 1996?
Your answer should be very brief. 0.81. What is the ratio of the Taxes (in constant 2015 US$) of Hungary in 1994 to that in 1996?
Provide a succinct answer. 0.9. What is the ratio of the Taxes (in constant 2015 US$) of Kazakhstan in 1994 to that in 1996?
Provide a short and direct response. 0.66. What is the ratio of the Taxes (in constant 2015 US$) in Bulgaria in 1994 to that in 1997?
Provide a short and direct response. 1.36. What is the ratio of the Taxes (in constant 2015 US$) of Costa Rica in 1994 to that in 1997?
Your answer should be very brief. 0.77. What is the ratio of the Taxes (in constant 2015 US$) in Hungary in 1994 to that in 1997?
Ensure brevity in your answer.  0.96. What is the ratio of the Taxes (in constant 2015 US$) of Kazakhstan in 1994 to that in 1997?
Offer a terse response. 0.68. What is the ratio of the Taxes (in constant 2015 US$) in Bulgaria in 1994 to that in 1998?
Keep it short and to the point. 0.86. What is the ratio of the Taxes (in constant 2015 US$) of Costa Rica in 1994 to that in 1998?
Your answer should be compact. 0.73. What is the ratio of the Taxes (in constant 2015 US$) of Hungary in 1994 to that in 1998?
Your answer should be compact. 0.92. What is the ratio of the Taxes (in constant 2015 US$) of Kazakhstan in 1994 to that in 1998?
Ensure brevity in your answer.  0.52. What is the ratio of the Taxes (in constant 2015 US$) in Bulgaria in 1995 to that in 1996?
Offer a terse response. 1.43. What is the ratio of the Taxes (in constant 2015 US$) of Costa Rica in 1995 to that in 1996?
Your answer should be very brief. 0.94. What is the ratio of the Taxes (in constant 2015 US$) of Hungary in 1995 to that in 1996?
Ensure brevity in your answer.  1.04. What is the ratio of the Taxes (in constant 2015 US$) of Kazakhstan in 1995 to that in 1996?
Your response must be concise. 0.85. What is the ratio of the Taxes (in constant 2015 US$) in Bulgaria in 1995 to that in 1997?
Your answer should be very brief. 1.48. What is the ratio of the Taxes (in constant 2015 US$) of Costa Rica in 1995 to that in 1997?
Offer a terse response. 0.89. What is the ratio of the Taxes (in constant 2015 US$) in Hungary in 1995 to that in 1997?
Provide a short and direct response. 1.1. What is the ratio of the Taxes (in constant 2015 US$) in Kazakhstan in 1995 to that in 1997?
Provide a short and direct response. 0.87. What is the ratio of the Taxes (in constant 2015 US$) of Bulgaria in 1995 to that in 1998?
Provide a succinct answer. 0.93. What is the ratio of the Taxes (in constant 2015 US$) of Costa Rica in 1995 to that in 1998?
Keep it short and to the point. 0.85. What is the ratio of the Taxes (in constant 2015 US$) in Hungary in 1995 to that in 1998?
Ensure brevity in your answer.  1.06. What is the ratio of the Taxes (in constant 2015 US$) of Kazakhstan in 1995 to that in 1998?
Your answer should be very brief. 0.67. What is the ratio of the Taxes (in constant 2015 US$) in Bulgaria in 1996 to that in 1997?
Offer a terse response. 1.03. What is the ratio of the Taxes (in constant 2015 US$) in Costa Rica in 1996 to that in 1997?
Offer a very short reply. 0.95. What is the ratio of the Taxes (in constant 2015 US$) in Hungary in 1996 to that in 1997?
Your answer should be compact. 1.06. What is the ratio of the Taxes (in constant 2015 US$) in Kazakhstan in 1996 to that in 1997?
Offer a terse response. 1.03. What is the ratio of the Taxes (in constant 2015 US$) of Bulgaria in 1996 to that in 1998?
Make the answer very short. 0.65. What is the ratio of the Taxes (in constant 2015 US$) of Costa Rica in 1996 to that in 1998?
Offer a terse response. 0.9. What is the ratio of the Taxes (in constant 2015 US$) of Hungary in 1996 to that in 1998?
Provide a short and direct response. 1.02. What is the ratio of the Taxes (in constant 2015 US$) in Kazakhstan in 1996 to that in 1998?
Give a very brief answer. 0.79. What is the ratio of the Taxes (in constant 2015 US$) of Bulgaria in 1997 to that in 1998?
Provide a short and direct response. 0.63. What is the ratio of the Taxes (in constant 2015 US$) in Costa Rica in 1997 to that in 1998?
Your answer should be compact. 0.95. What is the ratio of the Taxes (in constant 2015 US$) of Hungary in 1997 to that in 1998?
Make the answer very short. 0.96. What is the ratio of the Taxes (in constant 2015 US$) in Kazakhstan in 1997 to that in 1998?
Give a very brief answer. 0.77. What is the difference between the highest and the second highest Taxes (in constant 2015 US$) of Bulgaria?
Your response must be concise. 1.14e+08. What is the difference between the highest and the second highest Taxes (in constant 2015 US$) in Costa Rica?
Provide a short and direct response. 5.92e+07. What is the difference between the highest and the second highest Taxes (in constant 2015 US$) of Hungary?
Your response must be concise. 2.59e+08. What is the difference between the highest and the second highest Taxes (in constant 2015 US$) in Kazakhstan?
Provide a succinct answer. 1.06e+08. What is the difference between the highest and the lowest Taxes (in constant 2015 US$) in Bulgaria?
Give a very brief answer. 5.84e+08. What is the difference between the highest and the lowest Taxes (in constant 2015 US$) of Costa Rica?
Offer a very short reply. 3.95e+08. What is the difference between the highest and the lowest Taxes (in constant 2015 US$) of Hungary?
Make the answer very short. 1.30e+09. What is the difference between the highest and the lowest Taxes (in constant 2015 US$) of Kazakhstan?
Provide a short and direct response. 7.35e+08. 